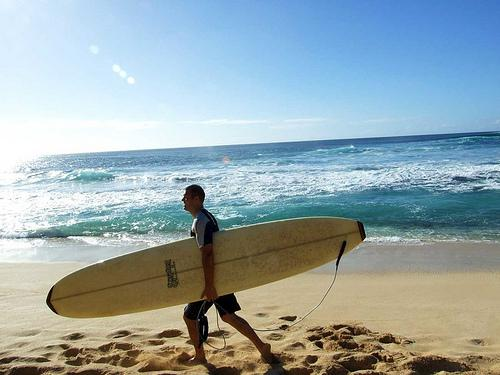Question: why the man is holding the surfboard?
Choices:
A. To show it to a customer.
B. To inspect the damage.
C. To help his son.
D. To surf.
Answer with the letter. Answer: D Question: who is holding the surfboard?
Choices:
A. The girl.
B. The surfer.
C. A teen.
D. A woman.
Answer with the letter. Answer: B 